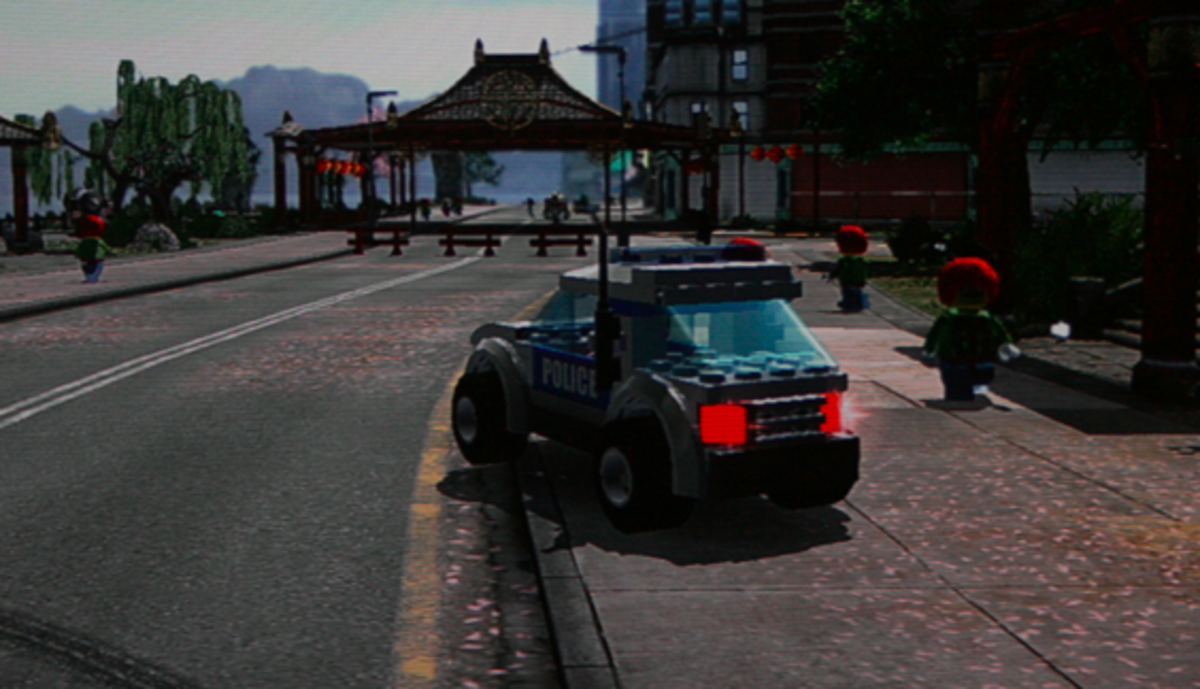Considering the stylization of the characters and the vehicle, what might be the intended audience for the video game from which this scene is likely taken, and why would this style appeal to them? The intended audience for this video game is likely young children and adults who enjoy playful, nostalgic themes. The visual style, characterized by colorful, block-like structures reminiscent of popular building toys, caters to younger audiences by offering a visually engaging, easily navigable, and imaginative landscape. This can stimulate creativity and problem-solving skills in a familiar, accessible gaming environment. For adults, such aesthetics often evoke a sense of nostalgia, potentially rekindling the joys of childhood and simpler times through interactive play. Additionally, the light-hearted, non-threatening portrayal of environments and characters makes it a suitable and appealing choice for family gaming sessions, encouraging bonding over shared challenges and achievements. 